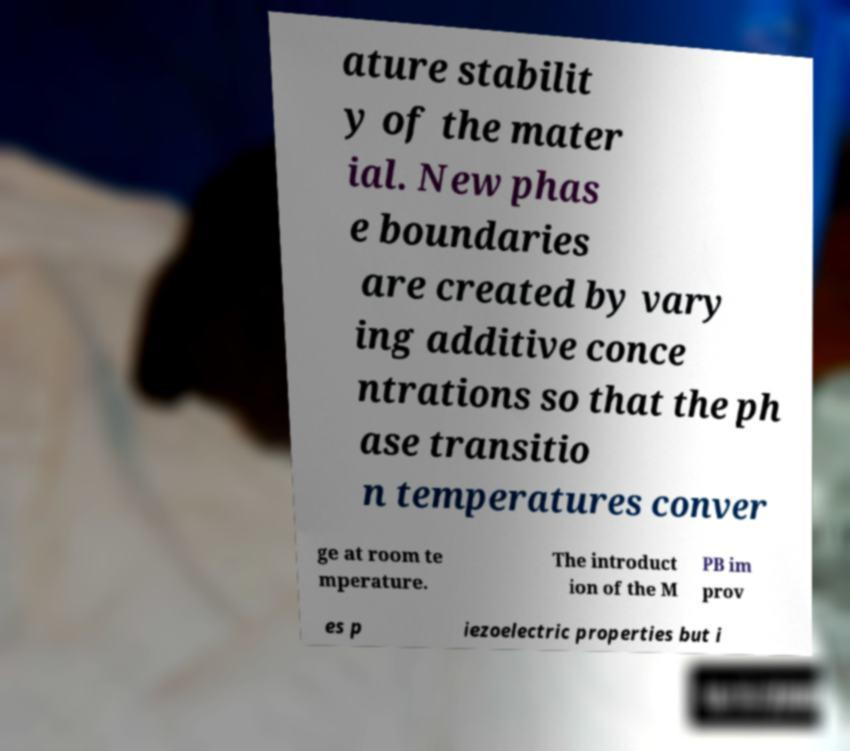For documentation purposes, I need the text within this image transcribed. Could you provide that? ature stabilit y of the mater ial. New phas e boundaries are created by vary ing additive conce ntrations so that the ph ase transitio n temperatures conver ge at room te mperature. The introduct ion of the M PB im prov es p iezoelectric properties but i 